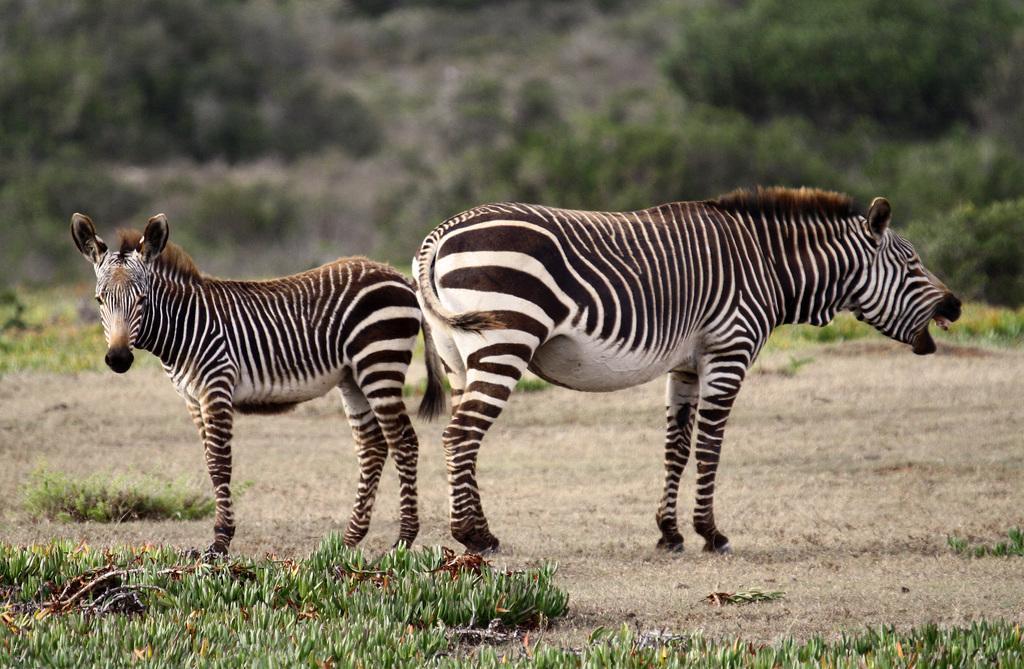In one or two sentences, can you explain what this image depicts? In this image I can see the grass and two zebras are standing in the front. In the background I can see plants and I can see this image is little bit blurry in the background. 